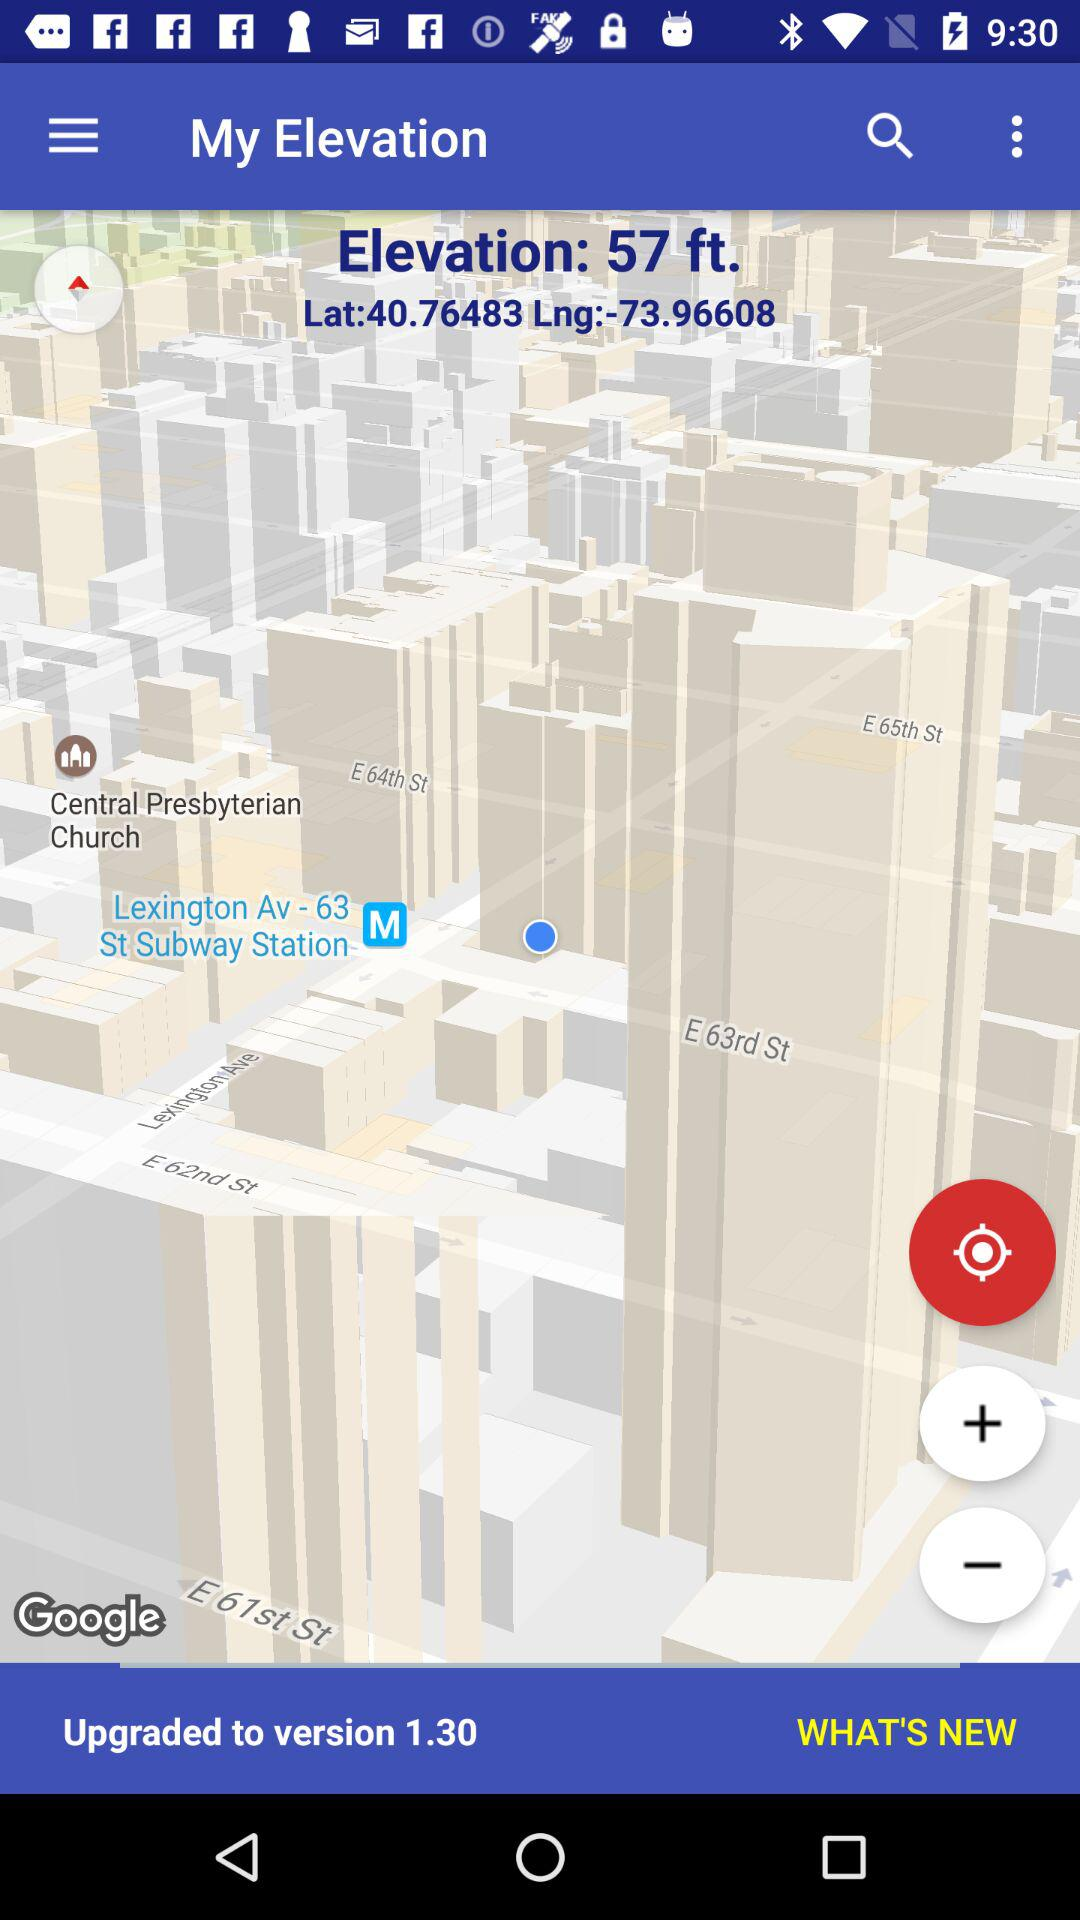What is the height of the elevation? The height of the elevation is 57 ft. 